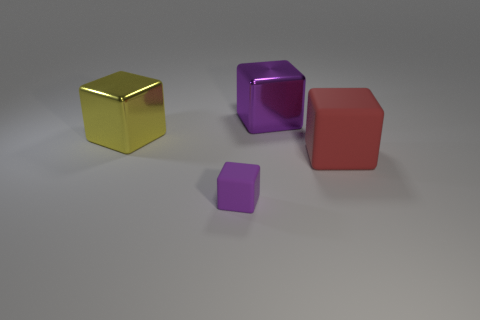Subtract all brown blocks. Subtract all cyan cylinders. How many blocks are left? 4 Add 2 big cyan rubber spheres. How many objects exist? 6 Add 3 large red blocks. How many large red blocks exist? 4 Subtract 0 purple cylinders. How many objects are left? 4 Subtract all gray rubber balls. Subtract all yellow metal things. How many objects are left? 3 Add 1 large yellow metallic blocks. How many large yellow metallic blocks are left? 2 